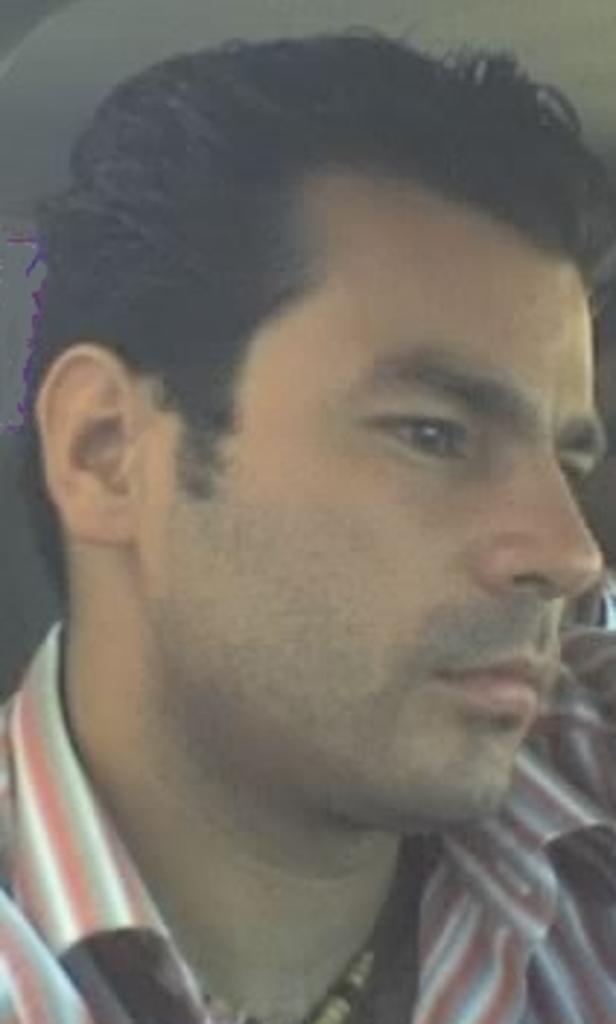How would you summarize this image in a sentence or two? In this picture we can see the face of a person. He is wearing a shirt. 